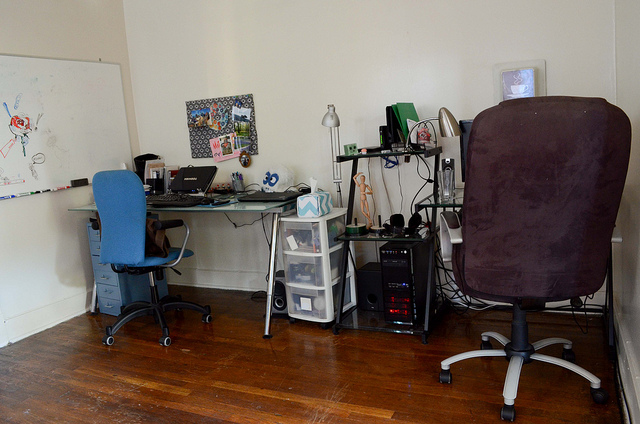Identify the text displayed in this image. 30 